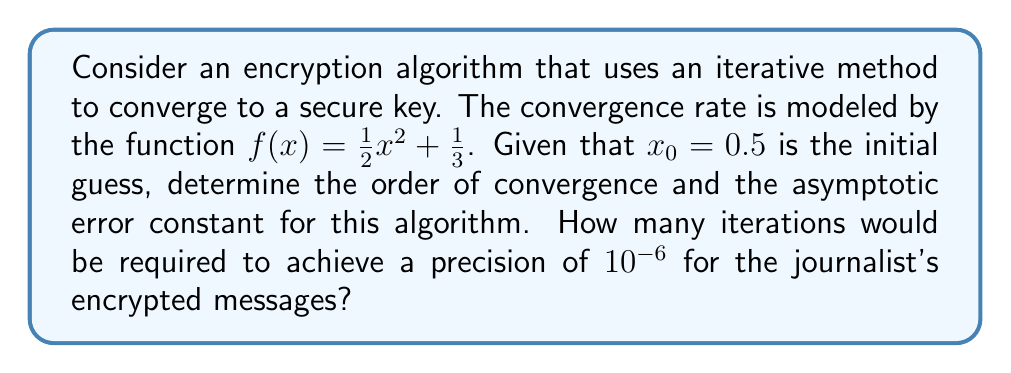Give your solution to this math problem. To solve this problem, we'll follow these steps:

1. Determine the fixed point of the iteration:
   Solve $f(x) = x$
   $$\frac{1}{2}x^2 + \frac{1}{3} = x$$
   $$\frac{1}{2}x^2 - x + \frac{1}{3} = 0$$
   Using the quadratic formula, we get $x = 1$ (the other root is negative and not relevant).

2. Calculate $f'(x)$ and $f''(x)$:
   $$f'(x) = x$$
   $$f''(x) = 1$$

3. Determine the order of convergence:
   For a fixed point iteration $x_{n+1} = f(x_n)$, the order of convergence $p$ is given by:
   $$p = \begin{cases}
   1 & \text{if } |f'(x^*)| < 1 \\
   2 & \text{if } f'(x^*) = 0 \text{ and } f''(x^*) \neq 0
   \end{cases}$$
   Where $x^*$ is the fixed point.
   
   Since $f'(1) = 1$, the order of convergence is 1 (linear convergence).

4. Calculate the asymptotic error constant:
   For linear convergence, the asymptotic error constant $C$ is given by $|f'(x^*)|$.
   $$C = |f'(1)| = 1$$

5. Estimate the number of iterations:
   For linear convergence, we can use the formula:
   $$n \approx \frac{\log(\epsilon / |x_0 - x^*|)}{\log(C)}$$
   Where $\epsilon$ is the desired precision and $x_0$ is the initial guess.
   
   $$n \approx \frac{\log(10^{-6} / |0.5 - 1|)}{\log(1)} = \infty$$

   This result indicates that the algorithm will not converge to the desired precision in a finite number of iterations, making it unsuitable for secure encryption.
Answer: Order of convergence: 1 (linear), Asymptotic error constant: 1, Iterations required: Infinite (does not converge to desired precision) 